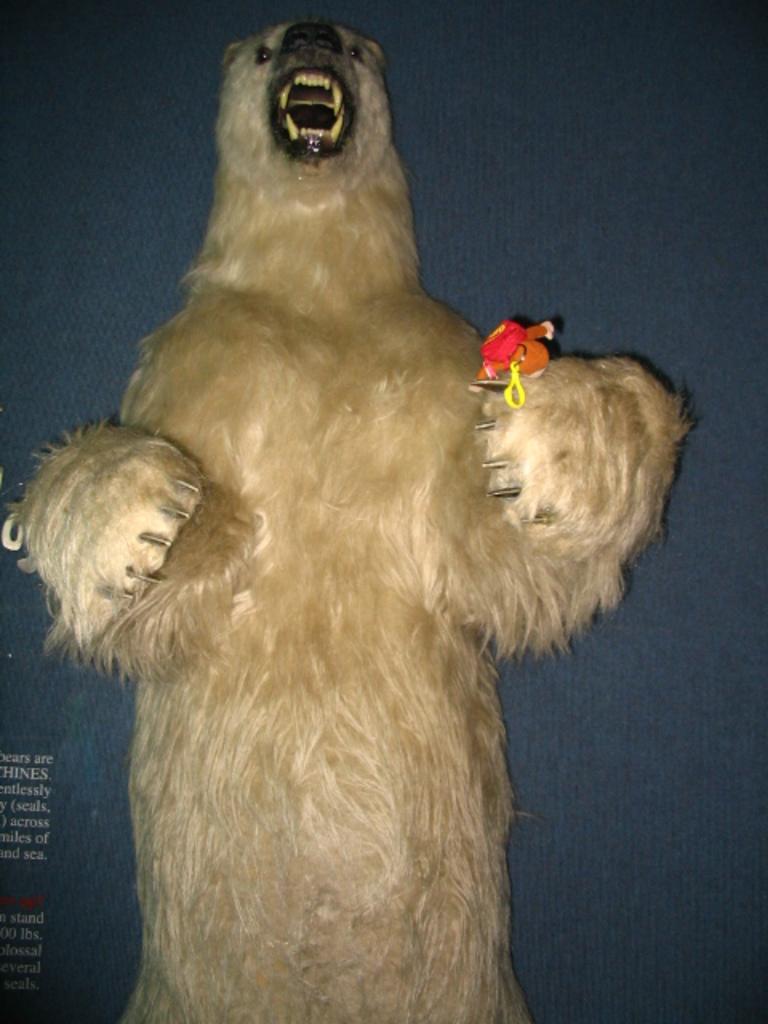Could you give a brief overview of what you see in this image? In this picture we can see a polar bear in the front, there is some text at the left bottom. 